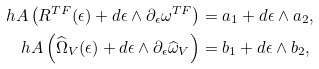Convert formula to latex. <formula><loc_0><loc_0><loc_500><loc_500>\ h A \left ( R ^ { T F } ( \epsilon ) + d \epsilon \wedge \partial _ { \epsilon } \omega ^ { T F } \right ) & = a _ { 1 } + d \epsilon \wedge a _ { 2 } , \\ \ h A \left ( \widehat { \Omega } _ { V } ( \epsilon ) + d \epsilon \wedge \partial _ { \epsilon } \widehat { \omega } _ { V } \right ) & = b _ { 1 } + d \epsilon \wedge b _ { 2 } ,</formula> 